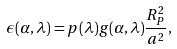Convert formula to latex. <formula><loc_0><loc_0><loc_500><loc_500>\epsilon ( \alpha , \lambda ) = p ( \lambda ) g ( \alpha , \lambda ) \frac { R _ { P } ^ { 2 } } { a ^ { 2 } } ,</formula> 